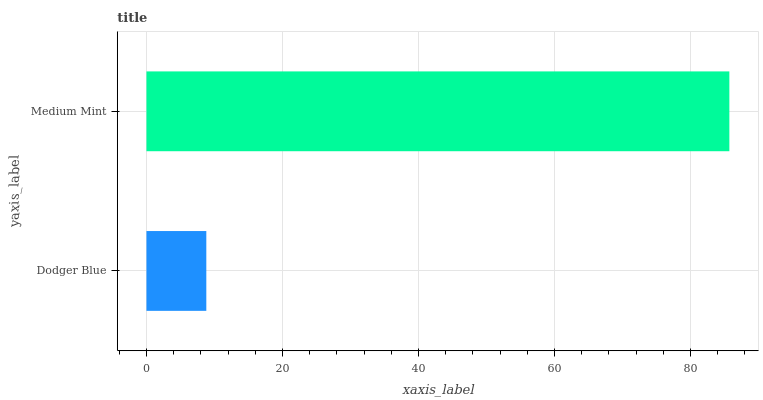Is Dodger Blue the minimum?
Answer yes or no. Yes. Is Medium Mint the maximum?
Answer yes or no. Yes. Is Medium Mint the minimum?
Answer yes or no. No. Is Medium Mint greater than Dodger Blue?
Answer yes or no. Yes. Is Dodger Blue less than Medium Mint?
Answer yes or no. Yes. Is Dodger Blue greater than Medium Mint?
Answer yes or no. No. Is Medium Mint less than Dodger Blue?
Answer yes or no. No. Is Medium Mint the high median?
Answer yes or no. Yes. Is Dodger Blue the low median?
Answer yes or no. Yes. Is Dodger Blue the high median?
Answer yes or no. No. Is Medium Mint the low median?
Answer yes or no. No. 